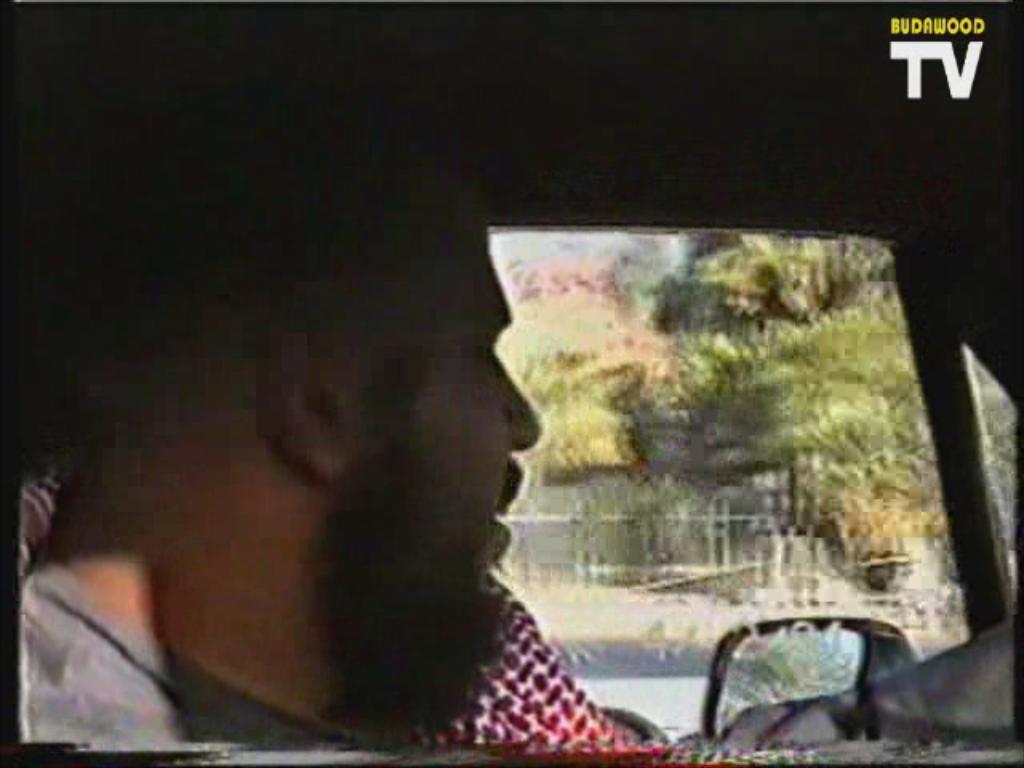Please provide a concise description of this image. In this picture there is a man on the left side of the image, inside a car and there are trees in the background area of the image. 